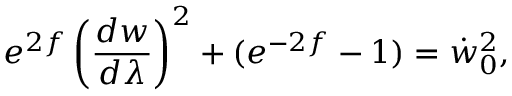Convert formula to latex. <formula><loc_0><loc_0><loc_500><loc_500>e ^ { 2 f } \left ( \frac { d w } { d \lambda } \right ) ^ { 2 } + ( e ^ { - 2 f } - 1 ) = \dot { w } _ { 0 } ^ { 2 } ,</formula> 